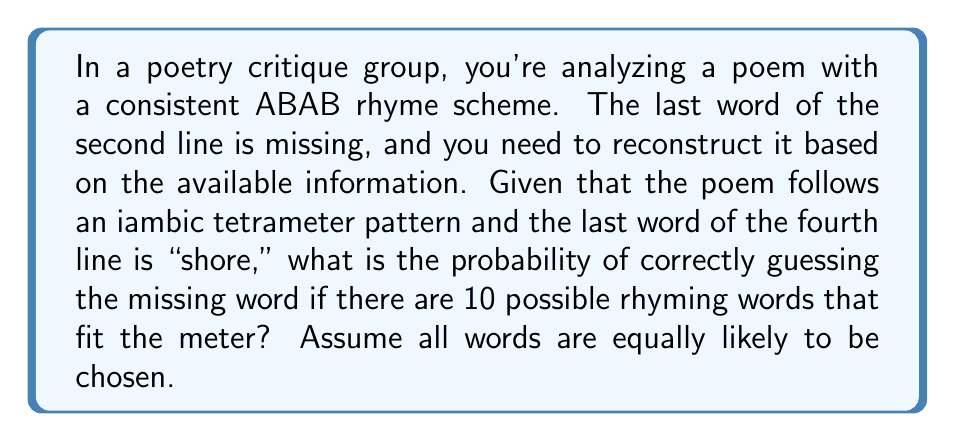Give your solution to this math problem. To solve this problem, we need to follow these steps:

1) First, we need to understand the given information:
   - The poem has an ABAB rhyme scheme
   - The missing word is in the second line (B rhyme)
   - The fourth line ends with "shore" (also B rhyme)
   - There are 10 possible rhyming words that fit the meter

2) Since the missing word needs to rhyme with "shore" and there are 10 possible words, we can treat this as a simple probability problem.

3) The probability of choosing the correct word is the number of favorable outcomes divided by the total number of possible outcomes:

   $$P(\text{correct guess}) = \frac{\text{number of correct words}}{\text{total number of possible words}}$$

4) In this case:
   - There is only 1 correct word (the original missing word)
   - There are 10 total possible words

5) Therefore, the probability is:

   $$P(\text{correct guess}) = \frac{1}{10} = 0.1$$

6) This can also be expressed as a percentage:

   $$0.1 \times 100\% = 10\%$$

Thus, the probability of correctly guessing the missing word is 0.1 or 10%.
Answer: 0.1 